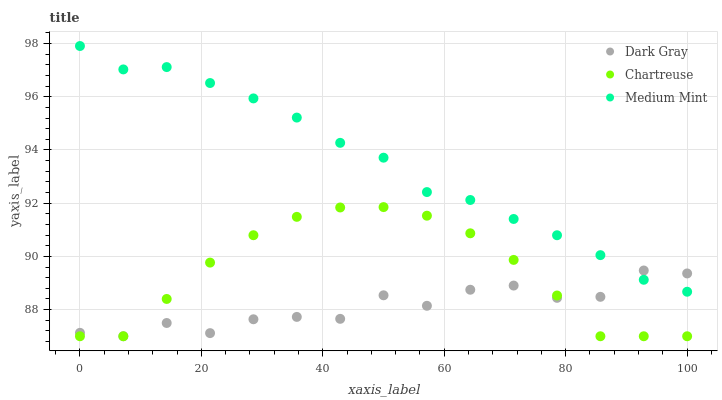Does Dark Gray have the minimum area under the curve?
Answer yes or no. Yes. Does Medium Mint have the maximum area under the curve?
Answer yes or no. Yes. Does Chartreuse have the minimum area under the curve?
Answer yes or no. No. Does Chartreuse have the maximum area under the curve?
Answer yes or no. No. Is Medium Mint the smoothest?
Answer yes or no. Yes. Is Dark Gray the roughest?
Answer yes or no. Yes. Is Chartreuse the smoothest?
Answer yes or no. No. Is Chartreuse the roughest?
Answer yes or no. No. Does Dark Gray have the lowest value?
Answer yes or no. Yes. Does Medium Mint have the lowest value?
Answer yes or no. No. Does Medium Mint have the highest value?
Answer yes or no. Yes. Does Chartreuse have the highest value?
Answer yes or no. No. Is Chartreuse less than Medium Mint?
Answer yes or no. Yes. Is Medium Mint greater than Chartreuse?
Answer yes or no. Yes. Does Chartreuse intersect Dark Gray?
Answer yes or no. Yes. Is Chartreuse less than Dark Gray?
Answer yes or no. No. Is Chartreuse greater than Dark Gray?
Answer yes or no. No. Does Chartreuse intersect Medium Mint?
Answer yes or no. No. 